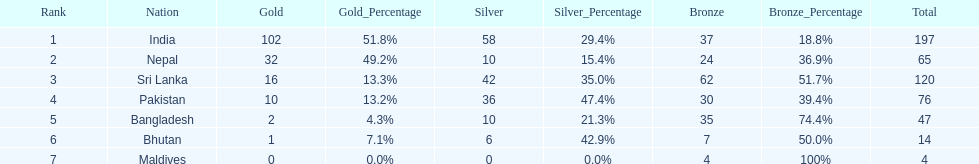Name a country listed in the table, other than india? Nepal. Help me parse the entirety of this table. {'header': ['Rank', 'Nation', 'Gold', 'Gold_Percentage', 'Silver', 'Silver_Percentage', 'Bronze', 'Bronze_Percentage', 'Total'], 'rows': [['1', 'India', '102', '51.8%', '58', '29.4%', '37', '18.8%', '197'], ['2', 'Nepal', '32', '49.2%', '10', '15.4%', '24', '36.9%', '65'], ['3', 'Sri Lanka', '16', '13.3%', '42', '35.0%', '62', '51.7%', '120'], ['4', 'Pakistan', '10', '13.2%', '36', '47.4%', '30', '39.4%', '76'], ['5', 'Bangladesh', '2', '4.3%', '10', '21.3%', '35', '74.4%', '47'], ['6', 'Bhutan', '1', '7.1%', '6', '42.9%', '7', '50.0%', '14'], ['7', 'Maldives', '0', '0.0%', '0', '0.0%', '4', '100%', '4']]} 